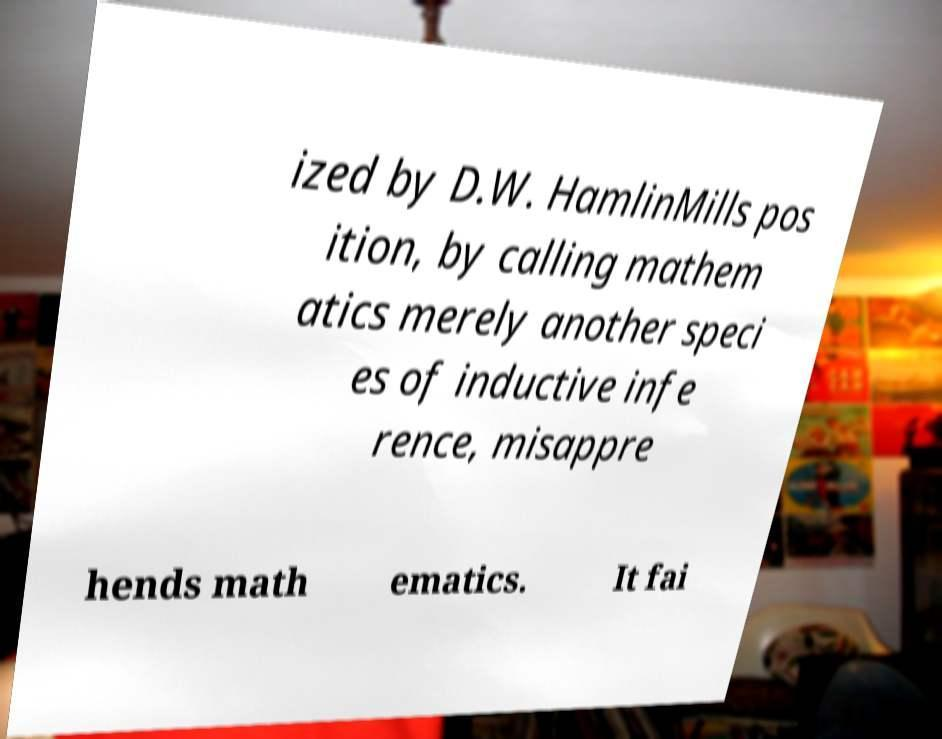Can you accurately transcribe the text from the provided image for me? ized by D.W. HamlinMills pos ition, by calling mathem atics merely another speci es of inductive infe rence, misappre hends math ematics. It fai 